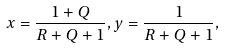<formula> <loc_0><loc_0><loc_500><loc_500>x = \frac { 1 + Q } { R + Q + 1 } , y = \frac { 1 } { R + Q + 1 } ,</formula> 